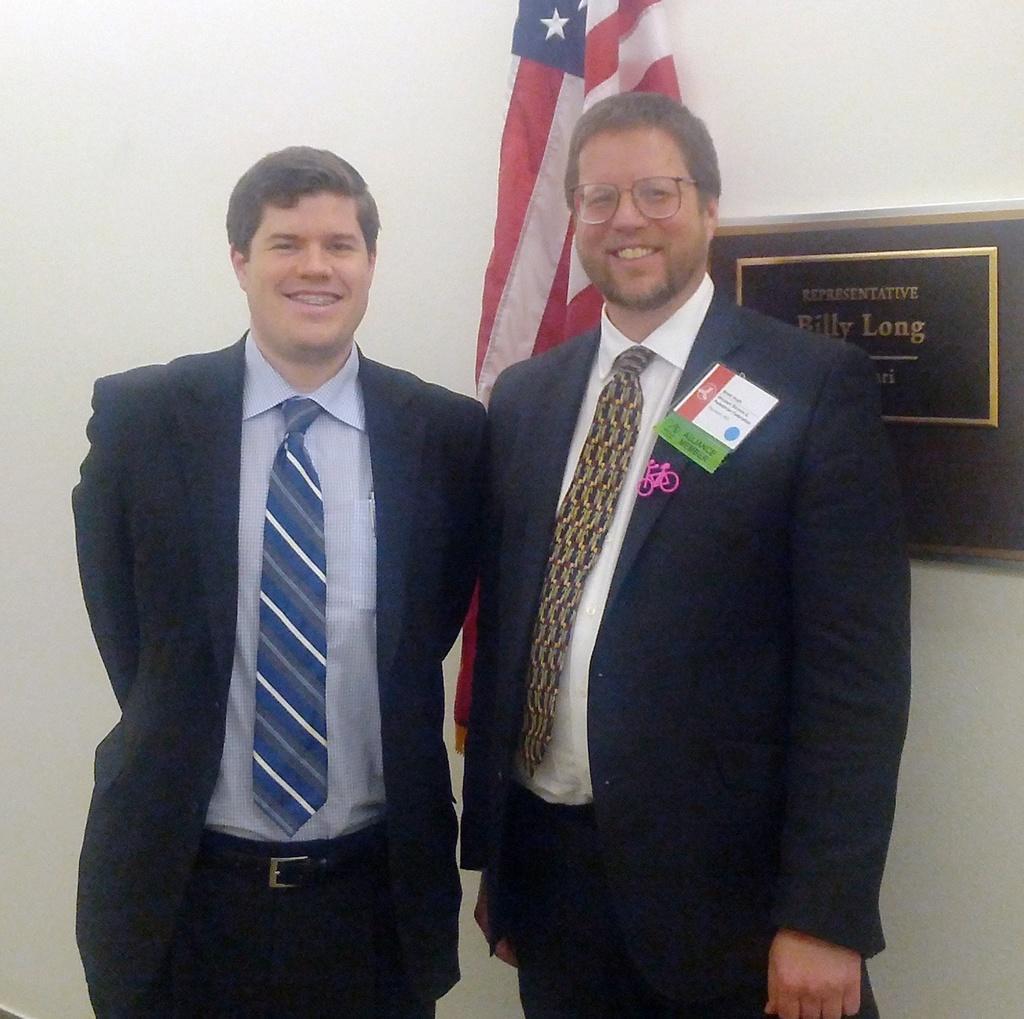In one or two sentences, can you explain what this image depicts? In this image I can see two persons standing, the person at left is wearing blue blazer, white shirt. In the background I can see the frame attached to the wall and I can also see the flag in red, white and blue color. 